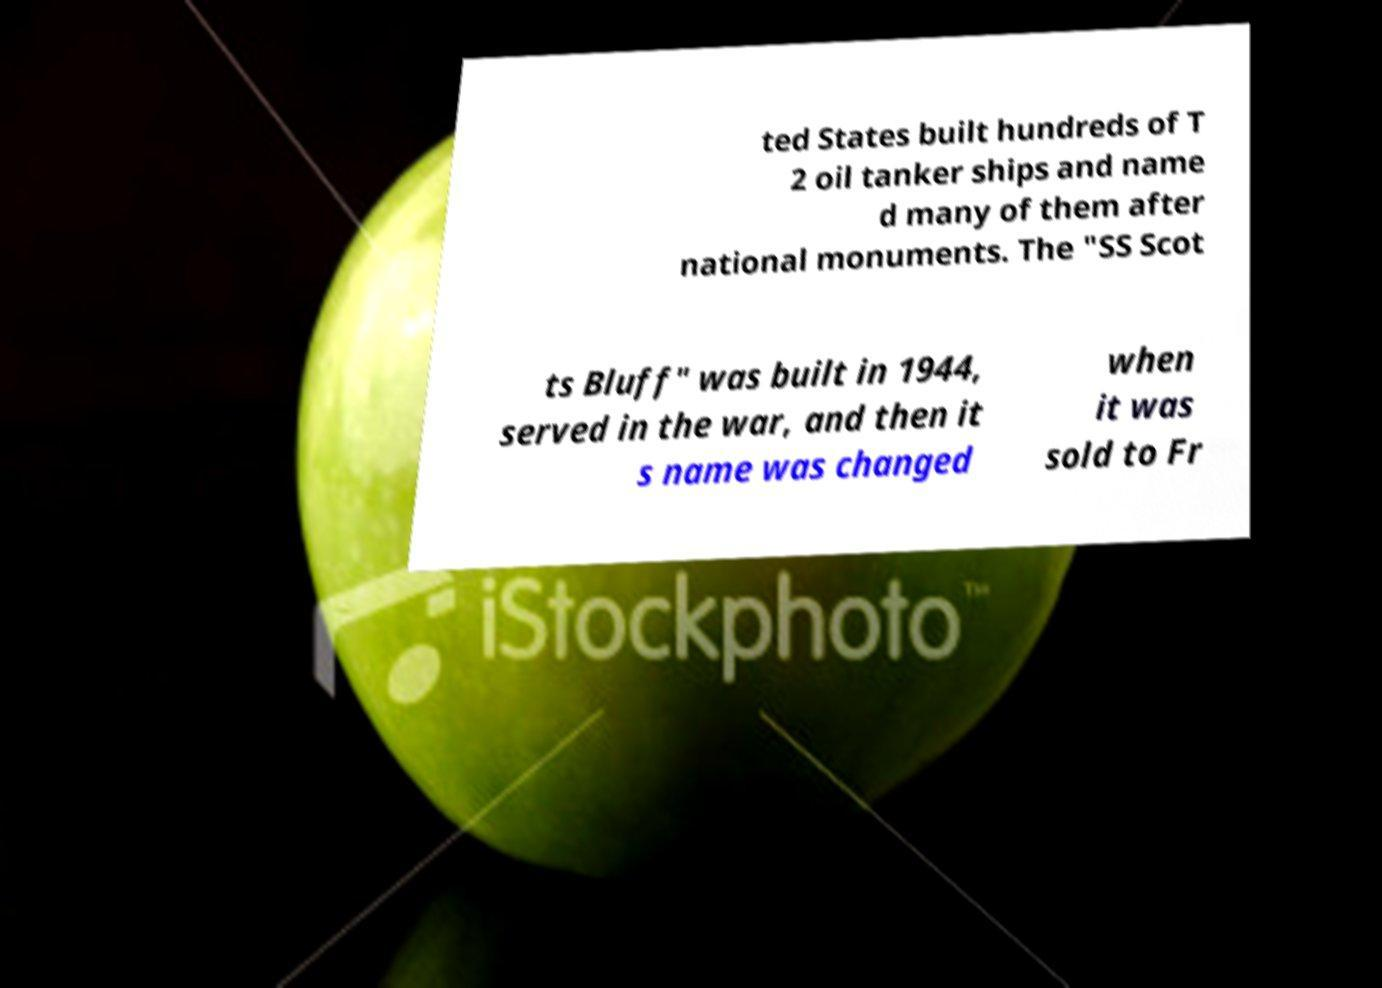Can you read and provide the text displayed in the image?This photo seems to have some interesting text. Can you extract and type it out for me? ted States built hundreds of T 2 oil tanker ships and name d many of them after national monuments. The "SS Scot ts Bluff" was built in 1944, served in the war, and then it s name was changed when it was sold to Fr 